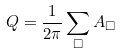Convert formula to latex. <formula><loc_0><loc_0><loc_500><loc_500>Q = \frac { 1 } { 2 \pi } \sum _ { \Box } A _ { \Box }</formula> 